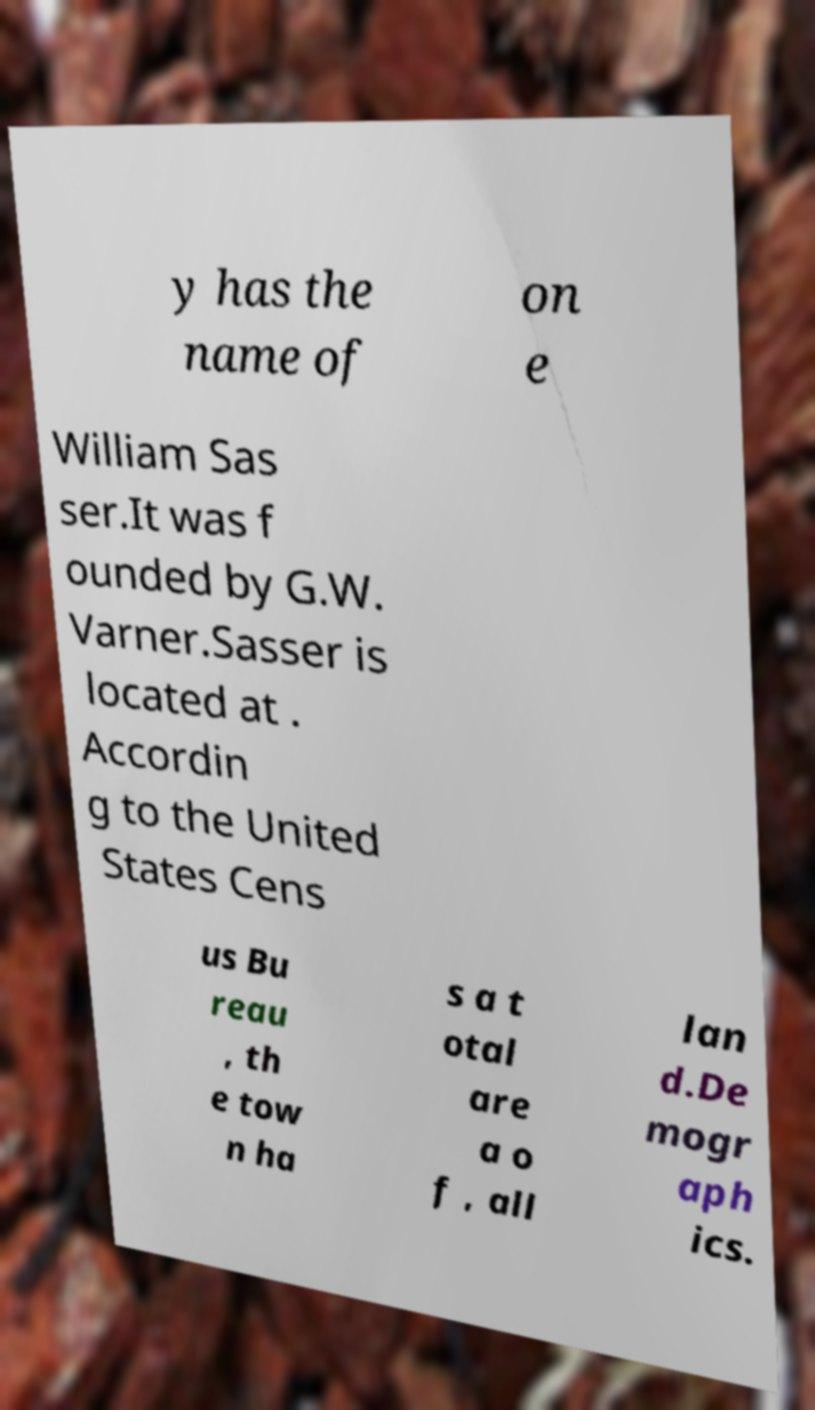There's text embedded in this image that I need extracted. Can you transcribe it verbatim? y has the name of on e William Sas ser.It was f ounded by G.W. Varner.Sasser is located at . Accordin g to the United States Cens us Bu reau , th e tow n ha s a t otal are a o f , all lan d.De mogr aph ics. 